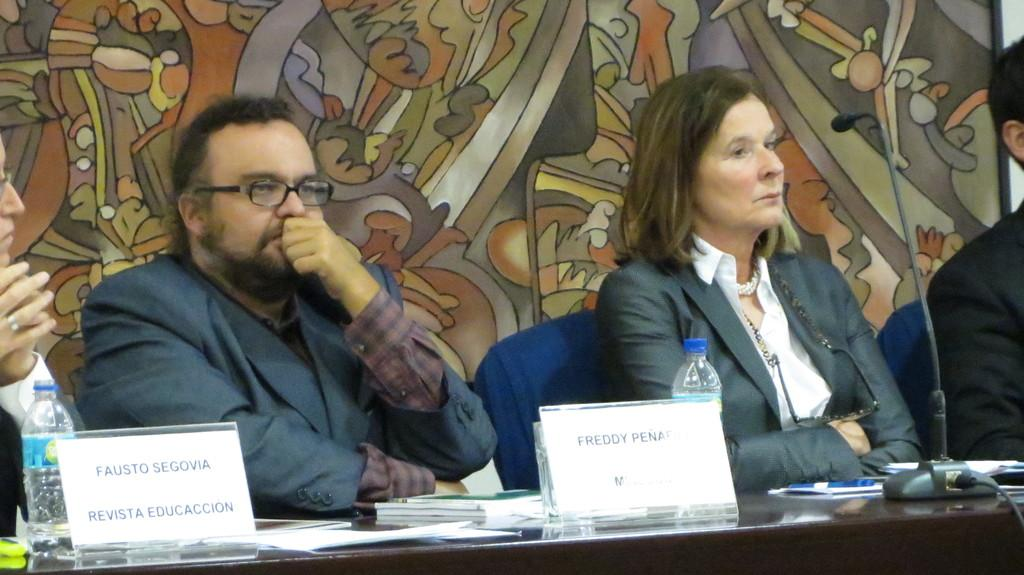What are the people in the image doing? The people in the image are sitting on chairs. What is in front of the chairs? There is a table in front of the chairs. What can be seen on the table? Name boards, bottles, a microphone (mic), books, and other things are on the table. What is the background of the image like? The background has a designed wall. What type of sweater is the person wearing in the image? There is no person wearing a sweater in the image; the people are sitting on chairs without any visible clothing items. 